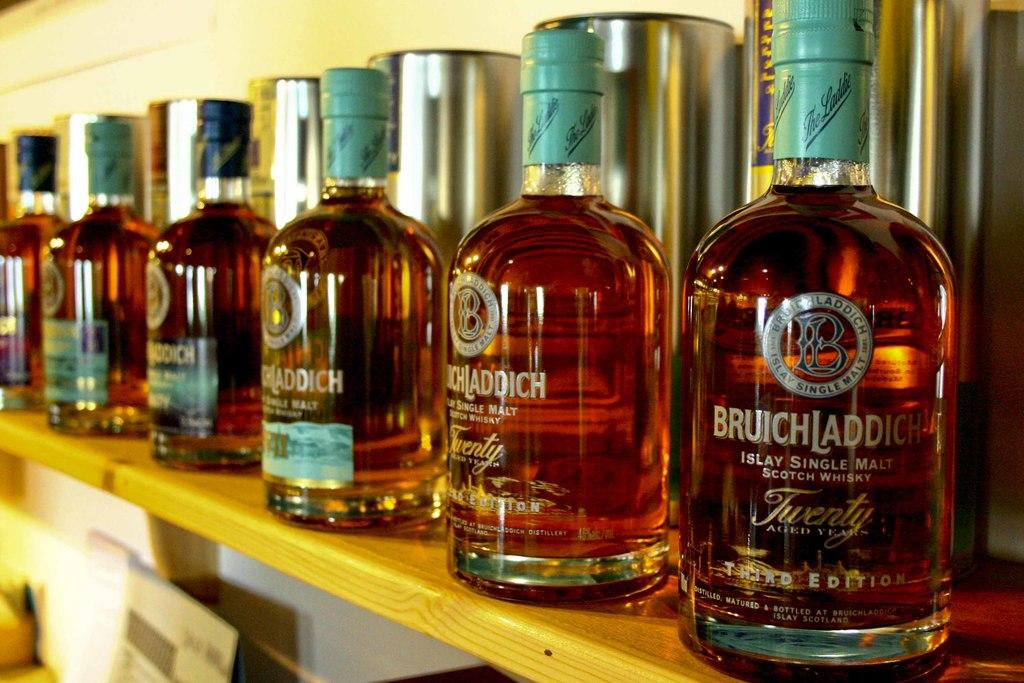How many whisky bottles are visible in the image? There are five whisky bottles in the image. Where are the whisky bottles located? The whisky bottles are kept on a shelf. What can be seen in the background of the image? There is a wall in the background of the image. What type of mark can be seen on the heart-shaped eggnog in the image? There is no mark on a heart-shaped eggnog in the image, as there are no eggnogs or hearts present. 